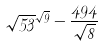Convert formula to latex. <formula><loc_0><loc_0><loc_500><loc_500>\sqrt { 5 3 } ^ { \sqrt { 9 } } - \frac { 4 9 4 } { \sqrt { 8 } }</formula> 